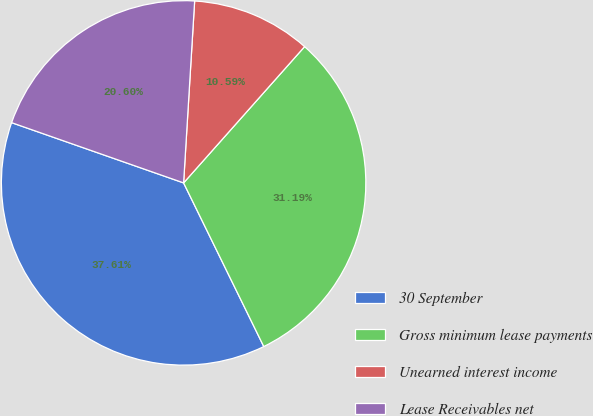<chart> <loc_0><loc_0><loc_500><loc_500><pie_chart><fcel>30 September<fcel>Gross minimum lease payments<fcel>Unearned interest income<fcel>Lease Receivables net<nl><fcel>37.61%<fcel>31.19%<fcel>10.59%<fcel>20.6%<nl></chart> 